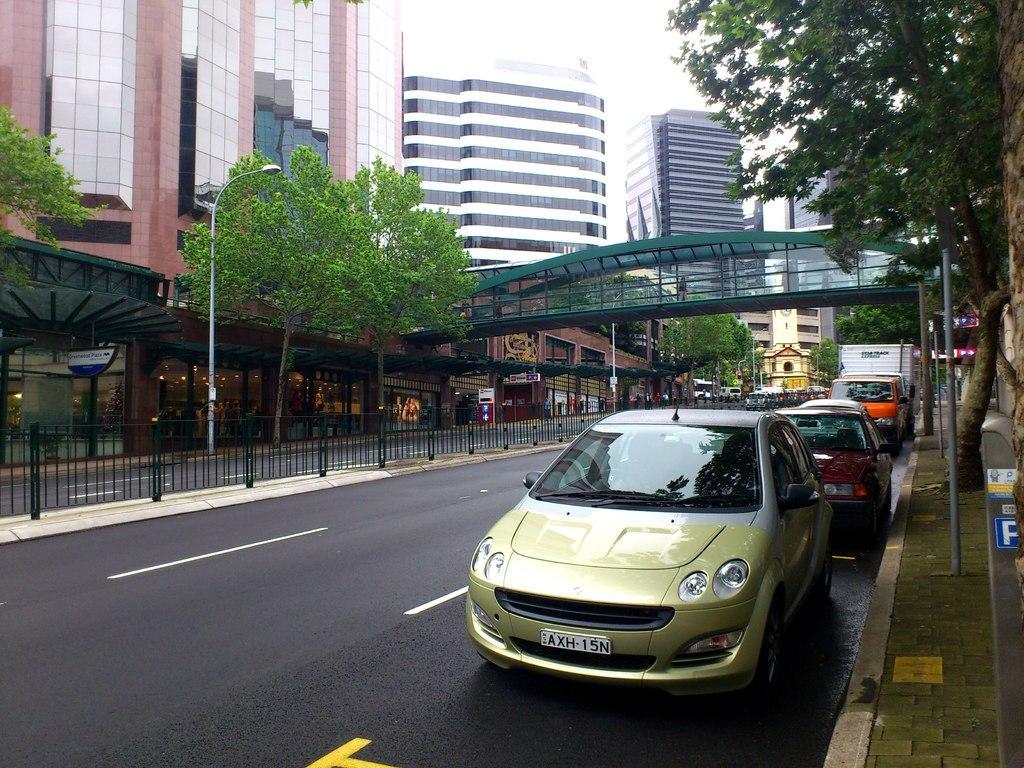Please provide a concise description of this image. In this image we can see few vehicles on the road, there is a light pole, few boards, poles, a railing, few trees, buildings, a bridge and the sky in the background. 